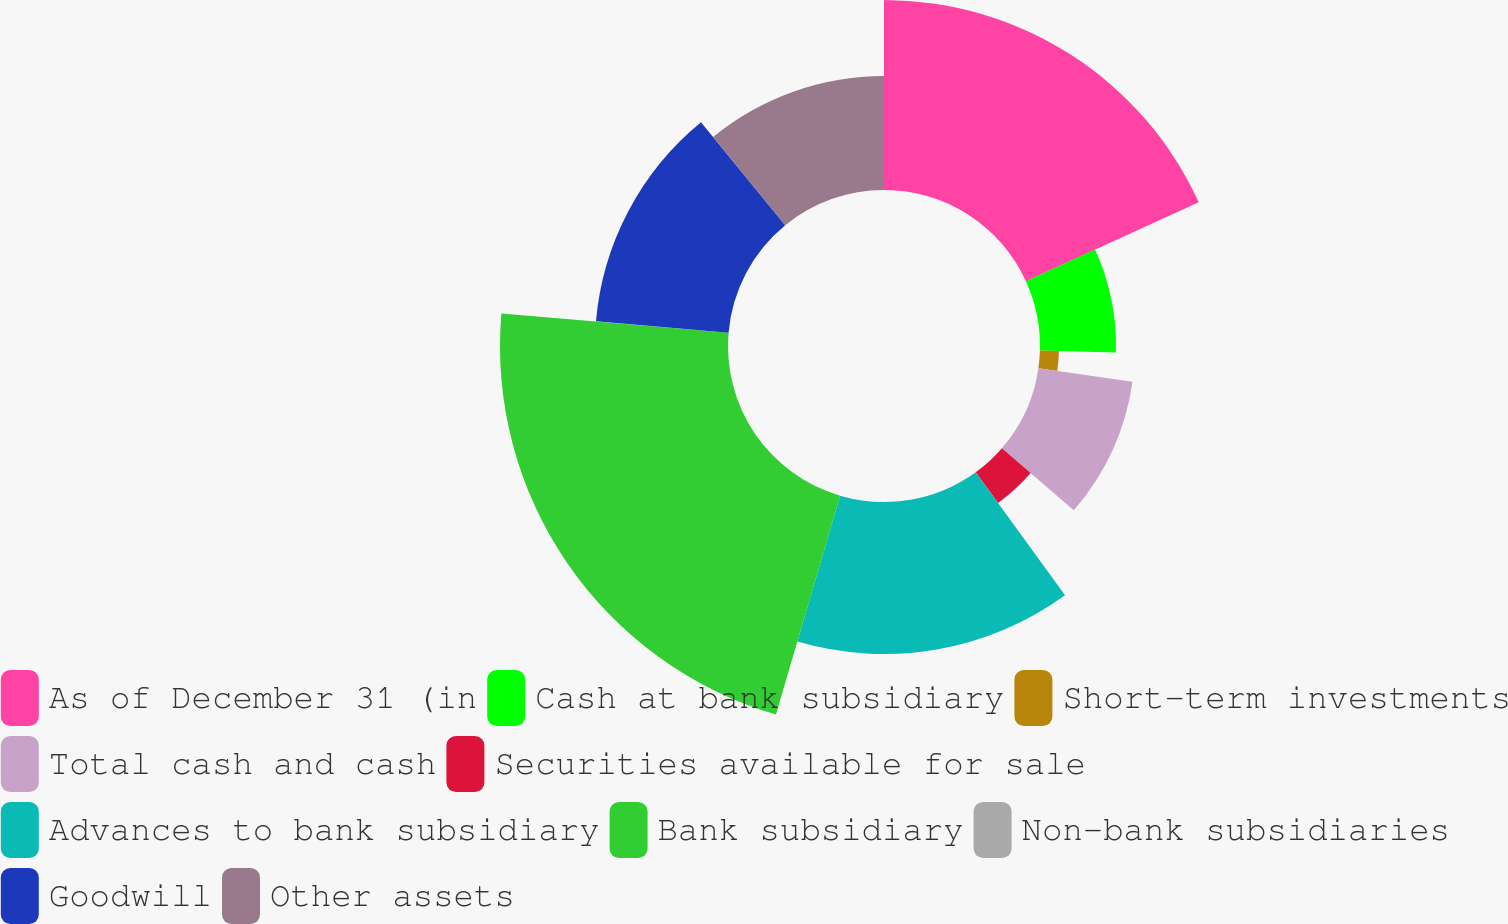Convert chart. <chart><loc_0><loc_0><loc_500><loc_500><pie_chart><fcel>As of December 31 (in<fcel>Cash at bank subsidiary<fcel>Short-term investments<fcel>Total cash and cash<fcel>Securities available for sale<fcel>Advances to bank subsidiary<fcel>Bank subsidiary<fcel>Non-bank subsidiaries<fcel>Goodwill<fcel>Other assets<nl><fcel>18.18%<fcel>7.27%<fcel>1.82%<fcel>9.09%<fcel>3.64%<fcel>14.54%<fcel>21.81%<fcel>0.01%<fcel>12.73%<fcel>10.91%<nl></chart> 